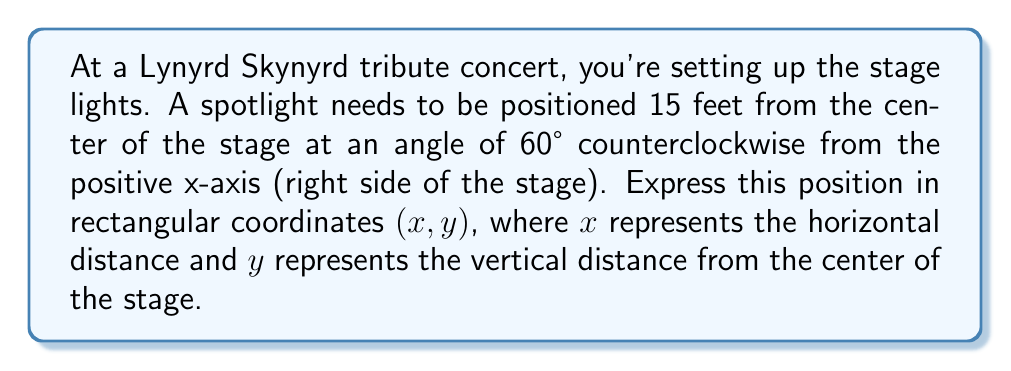Could you help me with this problem? Let's approach this step-by-step, using the conversion formulas from polar to rectangular coordinates:

1) In polar form, we have $r = 15$ and $\theta = 60°$.

2) The conversion formulas are:
   $x = r \cos(\theta)$
   $y = r \sin(\theta)$

3) For $x$:
   $x = 15 \cos(60°)$
   $= 15 \cdot \frac{1}{2} = 7.5$ feet

4) For $y$:
   $y = 15 \sin(60°)$
   $= 15 \cdot \frac{\sqrt{3}}{2} = 7.5\sqrt{3}$ feet

5) Therefore, the rectangular coordinates are $(7.5, 7.5\sqrt{3})$.

To visualize:

[asy]
import geometry;

size(200);
draw((-10,0)--(10,0),arrow=Arrow(TeXHead));
draw((0,-10)--(0,10),arrow=Arrow(TeXHead));
label("x", (10,0), E);
label("y", (0,10), N);

real r = 7.5;
real theta = pi/3;
pair P = (r*cos(theta), r*sin(theta));

draw((0,0)--P,arrow=Arrow(TeXHead), blue);
draw(arc((0,0), 3, 0, degrees(theta)), blue);
label("60°", (1.5,0.5), blue);
label("15", (r/2*cos(theta/2), r/2*sin(theta/2)), NW, blue);
dot(P, blue);
label("(7.5, 7.5√3)", P, NE, blue);
[/asy]
Answer: $(7.5, 7.5\sqrt{3})$ feet 